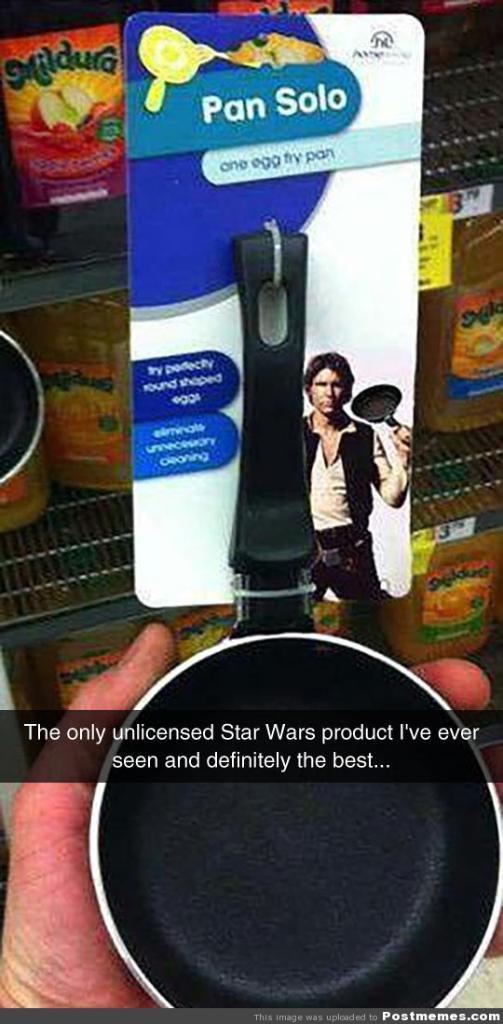Could you give a brief overview of what you see in this image? In this image we can see a person holding a pan, there is a card with a person's image and some text written on it is tied to that pan, and there are some food packets in the racks. 